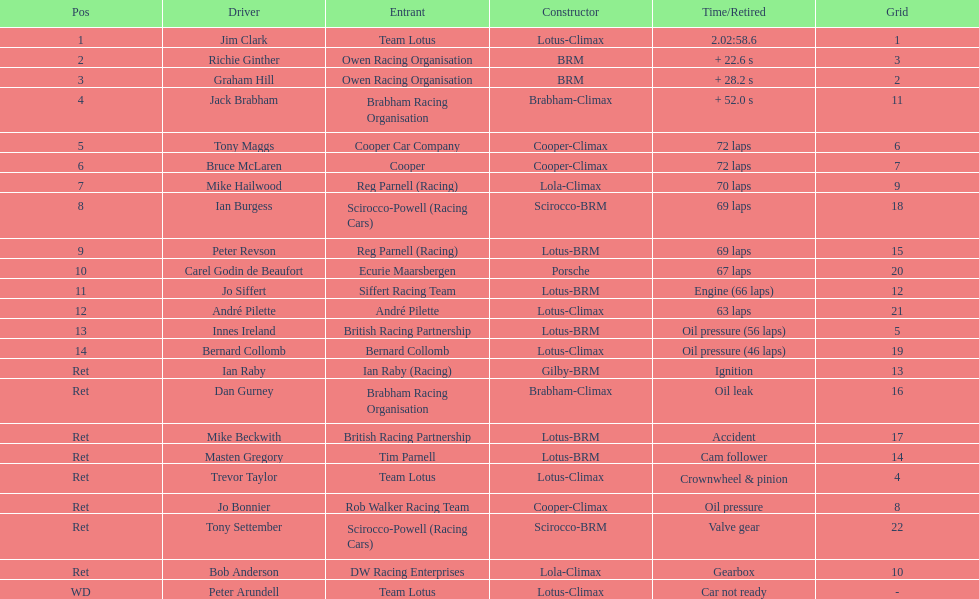How many distinct drivers are mentioned? 23. Give me the full table as a dictionary. {'header': ['Pos', 'Driver', 'Entrant', 'Constructor', 'Time/Retired', 'Grid'], 'rows': [['1', 'Jim Clark', 'Team Lotus', 'Lotus-Climax', '2.02:58.6', '1'], ['2', 'Richie Ginther', 'Owen Racing Organisation', 'BRM', '+ 22.6 s', '3'], ['3', 'Graham Hill', 'Owen Racing Organisation', 'BRM', '+ 28.2 s', '2'], ['4', 'Jack Brabham', 'Brabham Racing Organisation', 'Brabham-Climax', '+ 52.0 s', '11'], ['5', 'Tony Maggs', 'Cooper Car Company', 'Cooper-Climax', '72 laps', '6'], ['6', 'Bruce McLaren', 'Cooper', 'Cooper-Climax', '72 laps', '7'], ['7', 'Mike Hailwood', 'Reg Parnell (Racing)', 'Lola-Climax', '70 laps', '9'], ['8', 'Ian Burgess', 'Scirocco-Powell (Racing Cars)', 'Scirocco-BRM', '69 laps', '18'], ['9', 'Peter Revson', 'Reg Parnell (Racing)', 'Lotus-BRM', '69 laps', '15'], ['10', 'Carel Godin de Beaufort', 'Ecurie Maarsbergen', 'Porsche', '67 laps', '20'], ['11', 'Jo Siffert', 'Siffert Racing Team', 'Lotus-BRM', 'Engine (66 laps)', '12'], ['12', 'André Pilette', 'André Pilette', 'Lotus-Climax', '63 laps', '21'], ['13', 'Innes Ireland', 'British Racing Partnership', 'Lotus-BRM', 'Oil pressure (56 laps)', '5'], ['14', 'Bernard Collomb', 'Bernard Collomb', 'Lotus-Climax', 'Oil pressure (46 laps)', '19'], ['Ret', 'Ian Raby', 'Ian Raby (Racing)', 'Gilby-BRM', 'Ignition', '13'], ['Ret', 'Dan Gurney', 'Brabham Racing Organisation', 'Brabham-Climax', 'Oil leak', '16'], ['Ret', 'Mike Beckwith', 'British Racing Partnership', 'Lotus-BRM', 'Accident', '17'], ['Ret', 'Masten Gregory', 'Tim Parnell', 'Lotus-BRM', 'Cam follower', '14'], ['Ret', 'Trevor Taylor', 'Team Lotus', 'Lotus-Climax', 'Crownwheel & pinion', '4'], ['Ret', 'Jo Bonnier', 'Rob Walker Racing Team', 'Cooper-Climax', 'Oil pressure', '8'], ['Ret', 'Tony Settember', 'Scirocco-Powell (Racing Cars)', 'Scirocco-BRM', 'Valve gear', '22'], ['Ret', 'Bob Anderson', 'DW Racing Enterprises', 'Lola-Climax', 'Gearbox', '10'], ['WD', 'Peter Arundell', 'Team Lotus', 'Lotus-Climax', 'Car not ready', '-']]} 